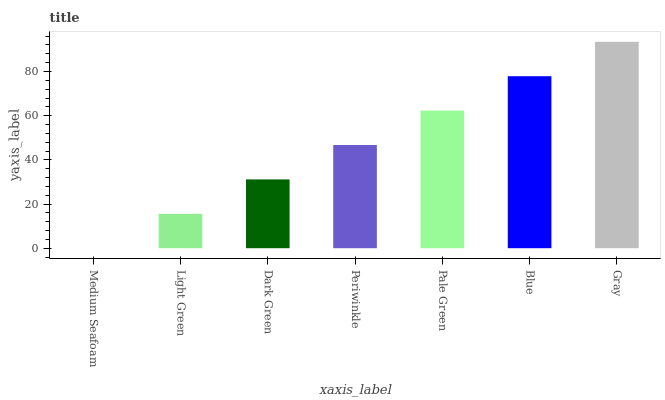Is Medium Seafoam the minimum?
Answer yes or no. Yes. Is Gray the maximum?
Answer yes or no. Yes. Is Light Green the minimum?
Answer yes or no. No. Is Light Green the maximum?
Answer yes or no. No. Is Light Green greater than Medium Seafoam?
Answer yes or no. Yes. Is Medium Seafoam less than Light Green?
Answer yes or no. Yes. Is Medium Seafoam greater than Light Green?
Answer yes or no. No. Is Light Green less than Medium Seafoam?
Answer yes or no. No. Is Periwinkle the high median?
Answer yes or no. Yes. Is Periwinkle the low median?
Answer yes or no. Yes. Is Light Green the high median?
Answer yes or no. No. Is Gray the low median?
Answer yes or no. No. 